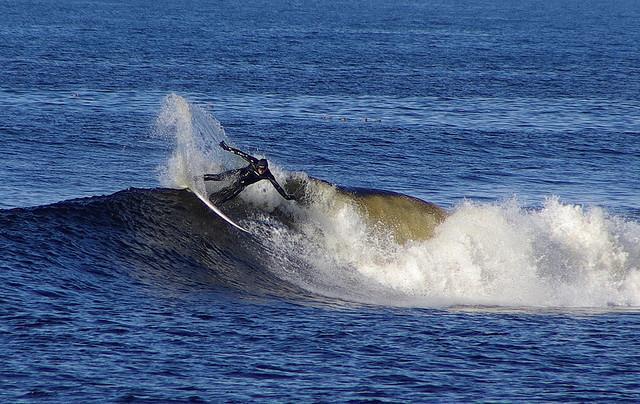How many people are in the water?
Give a very brief answer. 1. 